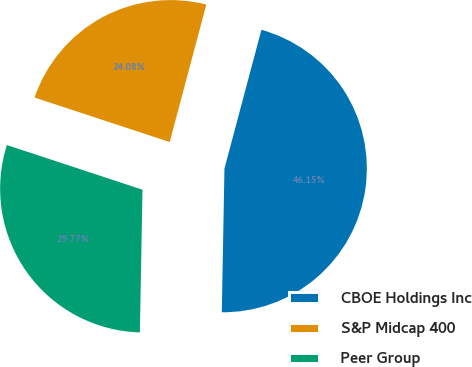Convert chart to OTSL. <chart><loc_0><loc_0><loc_500><loc_500><pie_chart><fcel>CBOE Holdings Inc<fcel>S&P Midcap 400<fcel>Peer Group<nl><fcel>46.15%<fcel>24.08%<fcel>29.77%<nl></chart> 